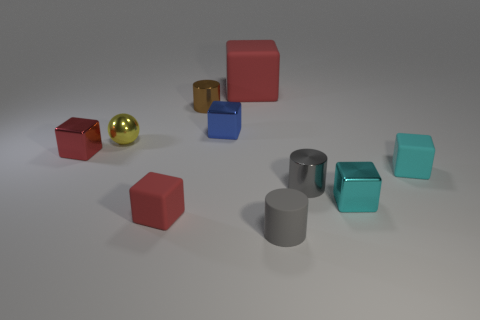Subtract all tiny gray cylinders. How many cylinders are left? 1 Subtract all cyan spheres. How many gray cylinders are left? 2 Subtract all gray cylinders. How many cylinders are left? 1 Subtract all spheres. How many objects are left? 9 Subtract 1 balls. How many balls are left? 0 Subtract all red spheres. Subtract all yellow blocks. How many spheres are left? 1 Subtract all big yellow matte cubes. Subtract all blue blocks. How many objects are left? 9 Add 8 metallic cylinders. How many metallic cylinders are left? 10 Add 8 tiny purple metallic balls. How many tiny purple metallic balls exist? 8 Subtract 0 purple spheres. How many objects are left? 10 